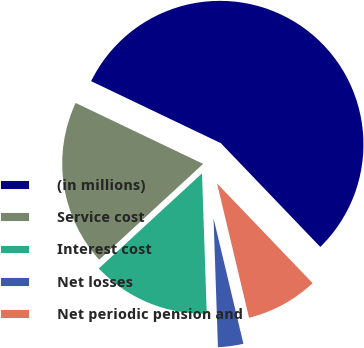Convert chart to OTSL. <chart><loc_0><loc_0><loc_500><loc_500><pie_chart><fcel>(in millions)<fcel>Service cost<fcel>Interest cost<fcel>Net losses<fcel>Net periodic pension and<nl><fcel>55.74%<fcel>18.95%<fcel>13.69%<fcel>3.18%<fcel>8.44%<nl></chart> 